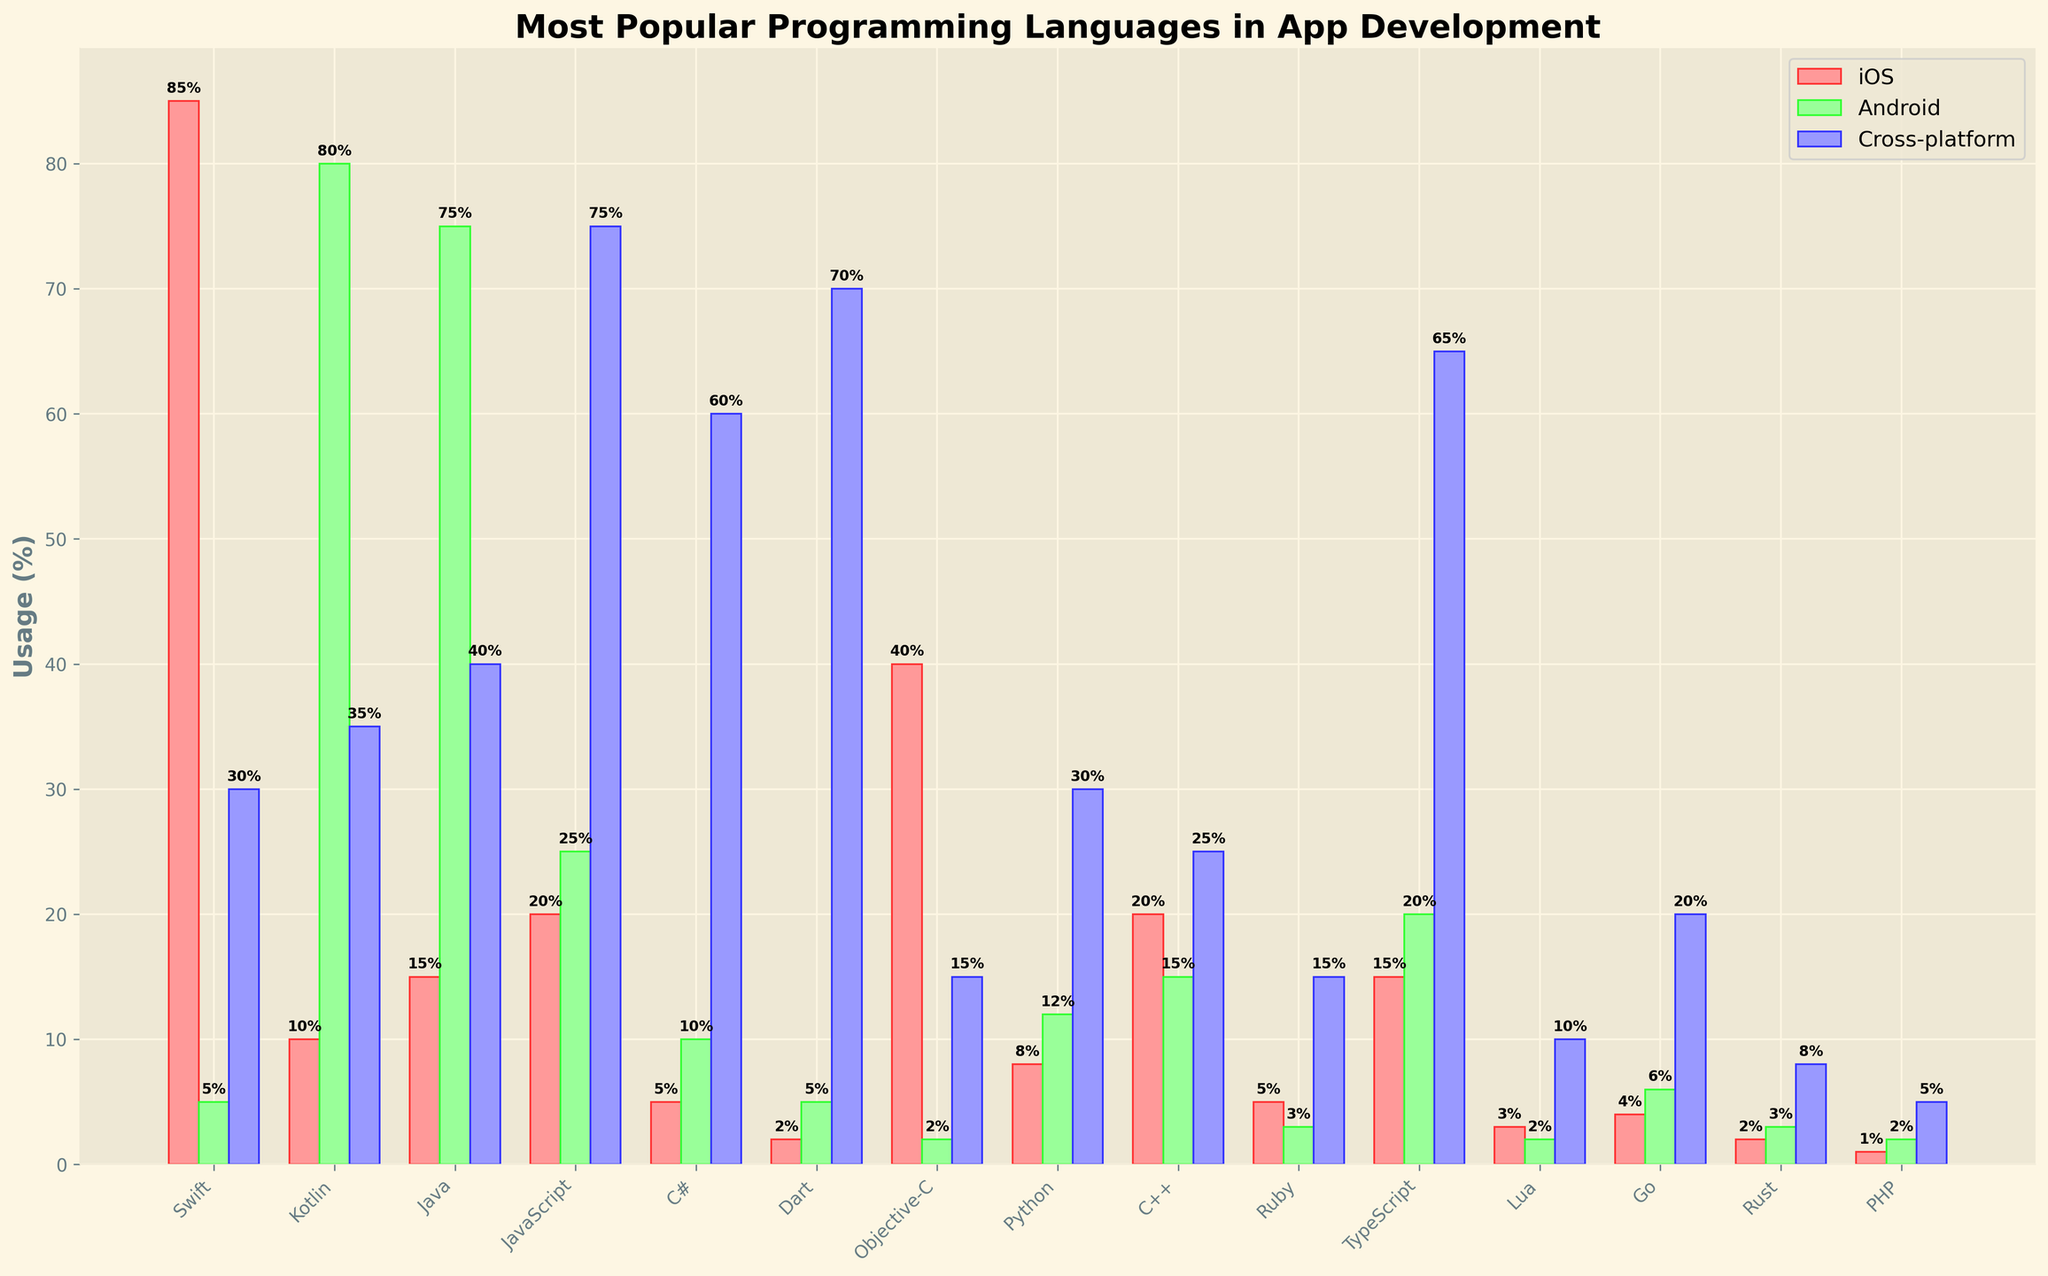What is the most popular programming language for iOS app development? The height of the red bars represents the usage percentage for iOS. The tallest red bar corresponds to Swift. By referring to the figure, we can see that Swift has the highest usage percentage for iOS.
Answer: Swift Which programming language has the highest usage in cross-platform development? By examining the heights of the purple bars representing cross-platform usage, the tallest bar is for JavaScript. Therefore, JavaScript has the highest usage in cross-platform development.
Answer: JavaScript Compare Swift and Kotlin in terms of usage for iOS and Android development. Which one is higher in each platform? For iOS, the red bar for Swift (85) is significantly higher than that for Kotlin (10). For Android, the green bar for Kotlin (80) is much higher than that for Swift (5).
Answer: Swift is higher for iOS, Kotlin is higher for Android What's the total usage percentage for Java in app development across all platforms? For Java, sum the three bars: iOS (15), Android (75), and Cross-platform (40). 15 + 75 + 40 = 130.
Answer: 130% How much greater is the usage of Swift for iOS compared to Android? The red bar for Swift shows 85% for iOS, and the green bar shows 5% for Android. The difference is 85 - 5 = 80.
Answer: 80% What is the least used programming language in Android development? The shortest green bar representing Android usage is for Objective-C (2%).
Answer: Objective-C Which programming language shows a notable balance between iOS, Android, and cross-platform usage? Examine languages with similar height bars across all platforms. C++ has relatively balanced usage: iOS (20), Android (15), and cross-platform (25), indicating a fairly even distribution.
Answer: C++ What is Python's usage percentage in cross-platform development? Refer to the height of the purple bar for Python in cross-platform. It shows 30%.
Answer: 30% Is there any language used more in iOS than cross-platform development? If so, which one? Compare the height of bars for iOS (red) and cross-platform (purple). Swift is used more for iOS (85) compared to cross-platform (30).
Answer: Swift Calculate the average cross-platform usage percentage for JavaScript, Dart, and TypeScript. JavaScript (75), Dart (70), and TypeScript (65). Sum these values: 75 + 70 + 65 = 210. Divide by the number of elements (3). 210 / 3 = 70.
Answer: 70 